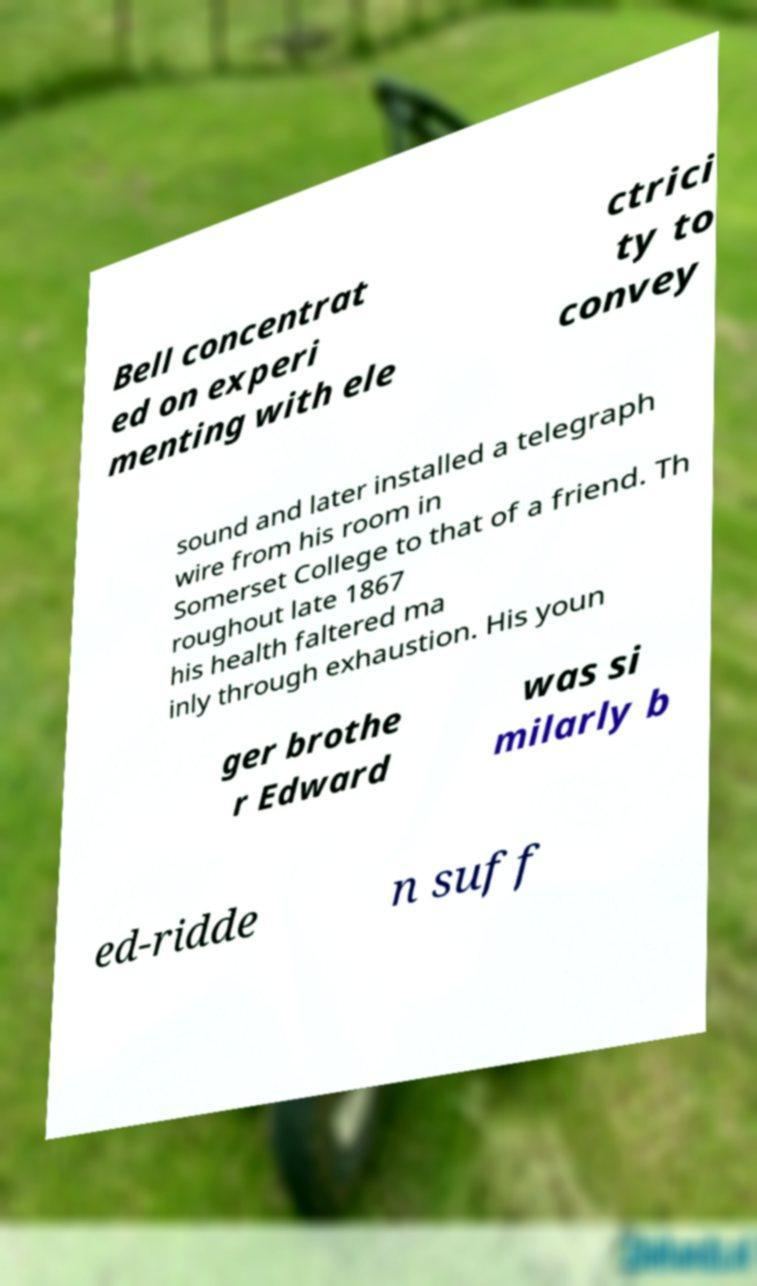Please read and relay the text visible in this image. What does it say? Bell concentrat ed on experi menting with ele ctrici ty to convey sound and later installed a telegraph wire from his room in Somerset College to that of a friend. Th roughout late 1867 his health faltered ma inly through exhaustion. His youn ger brothe r Edward was si milarly b ed-ridde n suff 